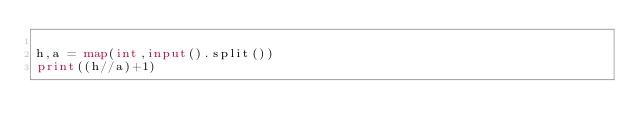Convert code to text. <code><loc_0><loc_0><loc_500><loc_500><_Python_>
h,a = map(int,input().split())
print((h//a)+1)
</code> 